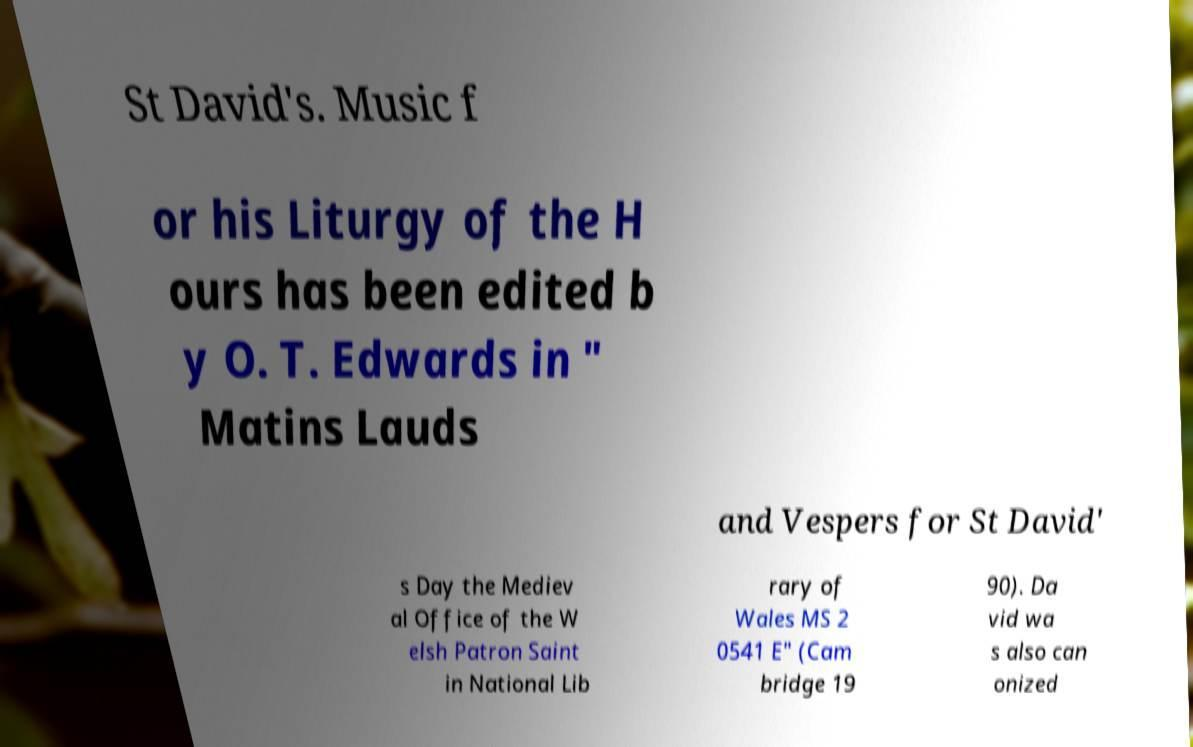Please identify and transcribe the text found in this image. St David's. Music f or his Liturgy of the H ours has been edited b y O. T. Edwards in " Matins Lauds and Vespers for St David' s Day the Mediev al Office of the W elsh Patron Saint in National Lib rary of Wales MS 2 0541 E" (Cam bridge 19 90). Da vid wa s also can onized 